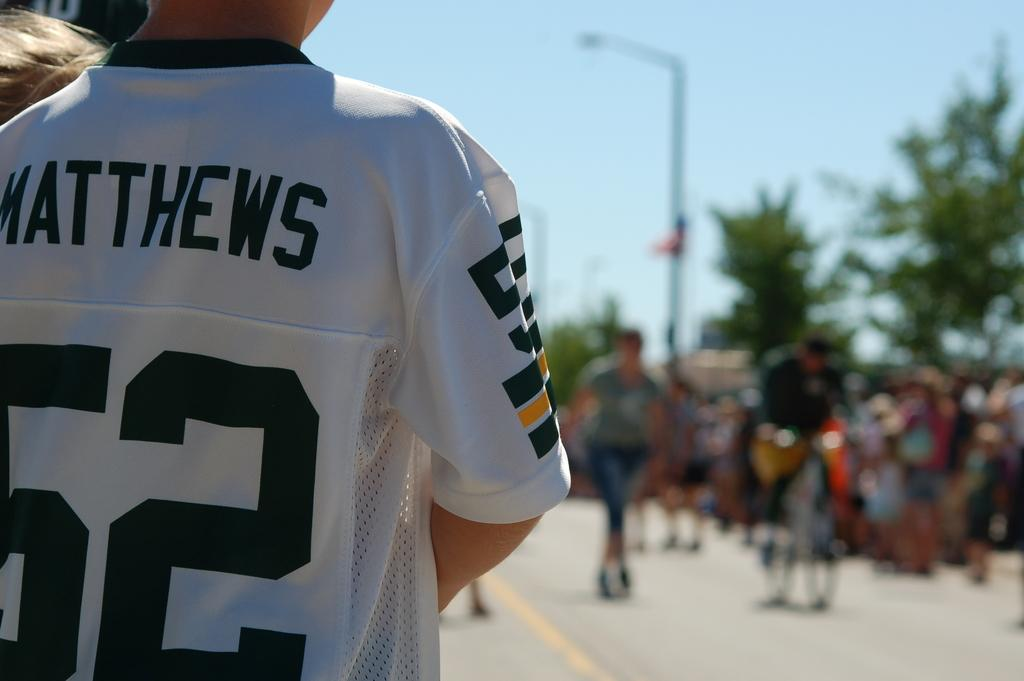<image>
Render a clear and concise summary of the photo. The boy has a Green Bay jersey on with the name Matthews. 